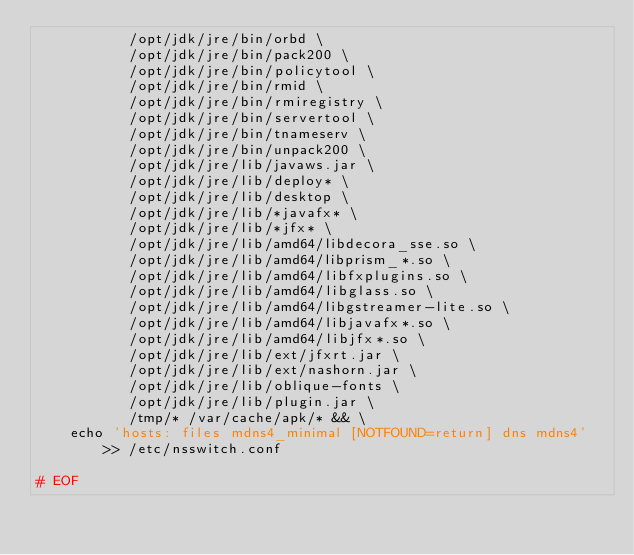Convert code to text. <code><loc_0><loc_0><loc_500><loc_500><_Dockerfile_>           /opt/jdk/jre/bin/orbd \
           /opt/jdk/jre/bin/pack200 \
           /opt/jdk/jre/bin/policytool \
           /opt/jdk/jre/bin/rmid \
           /opt/jdk/jre/bin/rmiregistry \
           /opt/jdk/jre/bin/servertool \
           /opt/jdk/jre/bin/tnameserv \
           /opt/jdk/jre/bin/unpack200 \
           /opt/jdk/jre/lib/javaws.jar \
           /opt/jdk/jre/lib/deploy* \
           /opt/jdk/jre/lib/desktop \
           /opt/jdk/jre/lib/*javafx* \
           /opt/jdk/jre/lib/*jfx* \
           /opt/jdk/jre/lib/amd64/libdecora_sse.so \
           /opt/jdk/jre/lib/amd64/libprism_*.so \
           /opt/jdk/jre/lib/amd64/libfxplugins.so \
           /opt/jdk/jre/lib/amd64/libglass.so \
           /opt/jdk/jre/lib/amd64/libgstreamer-lite.so \
           /opt/jdk/jre/lib/amd64/libjavafx*.so \
           /opt/jdk/jre/lib/amd64/libjfx*.so \
           /opt/jdk/jre/lib/ext/jfxrt.jar \
           /opt/jdk/jre/lib/ext/nashorn.jar \
           /opt/jdk/jre/lib/oblique-fonts \
           /opt/jdk/jre/lib/plugin.jar \
           /tmp/* /var/cache/apk/* && \
    echo 'hosts: files mdns4_minimal [NOTFOUND=return] dns mdns4' >> /etc/nsswitch.conf

# EOF
</code> 